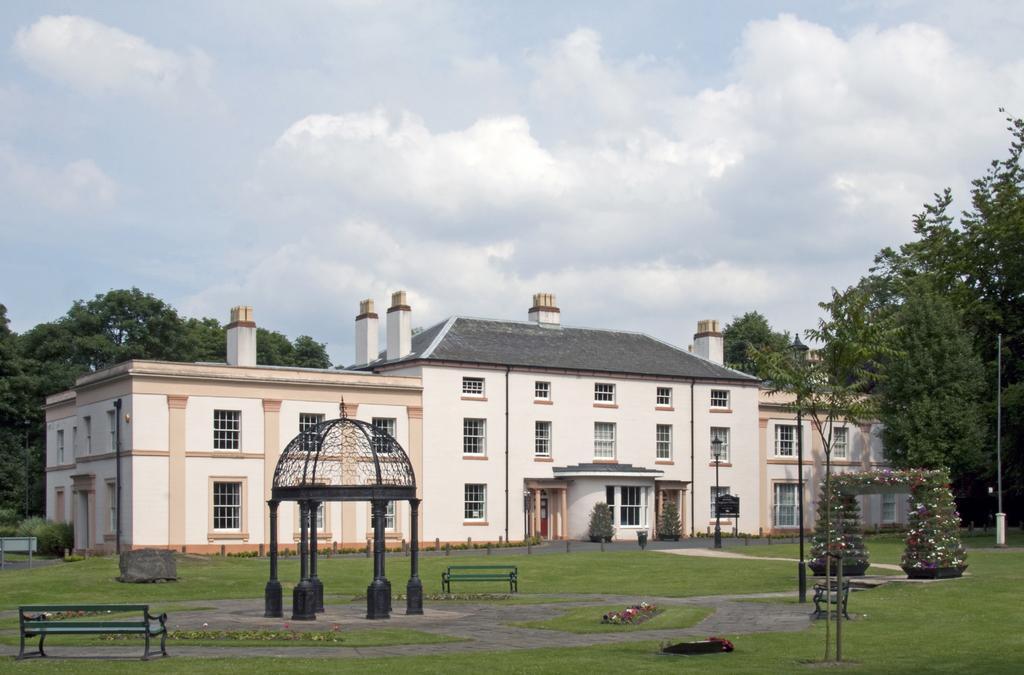How would you summarize this image in a sentence or two? In this image we can see a white color building. In front of the building grassy land, benches, plants, poles and one black color shelters are there. Right side of the image and behind the building trees are present. Top of the image sky is covered with clouds. 